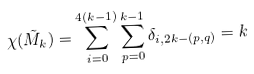Convert formula to latex. <formula><loc_0><loc_0><loc_500><loc_500>\chi ( \tilde { M } _ { k } ) = \sum _ { i = 0 } ^ { 4 ( k - 1 ) } \sum _ { p = 0 } ^ { k - 1 } \delta _ { i , 2 k - ( p , q ) } = k</formula> 